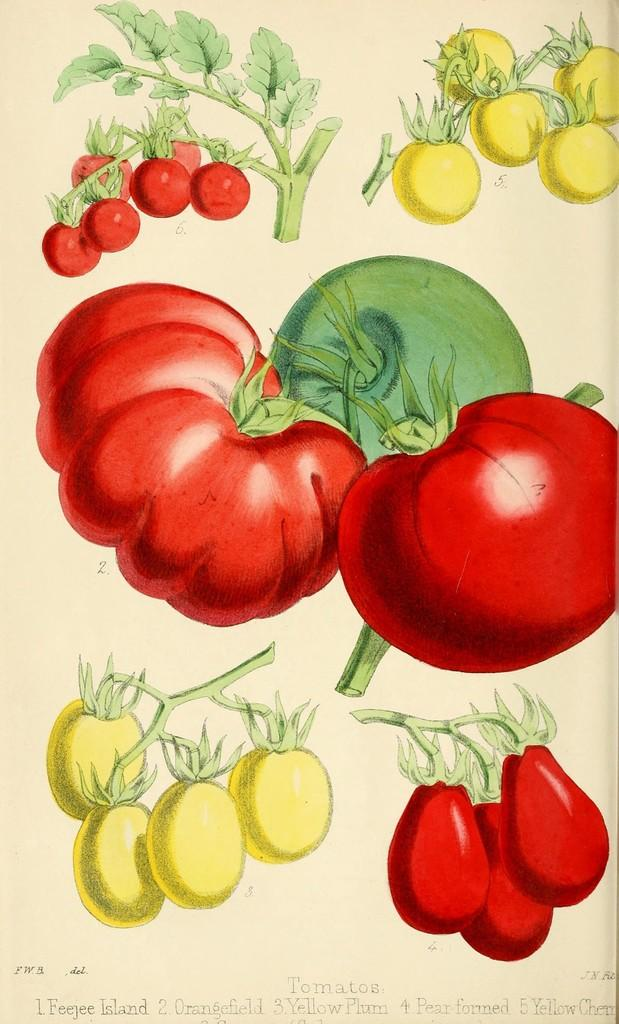What type of natural elements are depicted in the image? The image contains a depiction of leaves and vegetables. What can be found at the bottom of the image? There is text written at the bottom of the image. How many toads are jumping in the image? There are no toads present in the image. What type of debt is being discussed in the image? The image does not mention or depict any debt; it contains a depiction of leaves and vegetables with text at the bottom. 